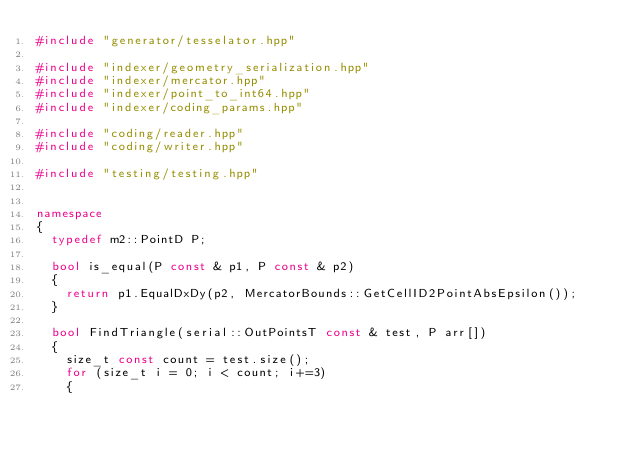<code> <loc_0><loc_0><loc_500><loc_500><_C++_>#include "generator/tesselator.hpp"

#include "indexer/geometry_serialization.hpp"
#include "indexer/mercator.hpp"
#include "indexer/point_to_int64.hpp"
#include "indexer/coding_params.hpp"

#include "coding/reader.hpp"
#include "coding/writer.hpp"

#include "testing/testing.hpp"


namespace
{
  typedef m2::PointD P;

  bool is_equal(P const & p1, P const & p2)
  {
    return p1.EqualDxDy(p2, MercatorBounds::GetCellID2PointAbsEpsilon());
  }

  bool FindTriangle(serial::OutPointsT const & test, P arr[])
  {
    size_t const count = test.size();
    for (size_t i = 0; i < count; i+=3)
    {</code> 